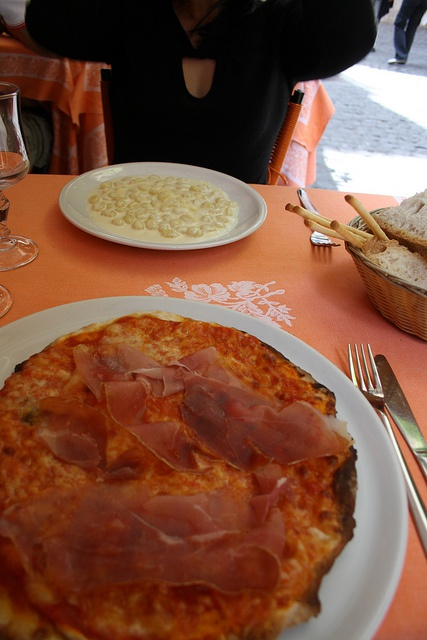Describe the objects in this image and their specific colors. I can see dining table in gray, maroon, brown, and darkgray tones, pizza in gray, maroon, and brown tones, people in gray, black, and maroon tones, fork in gray, ivory, darkgray, and maroon tones, and knife in gray, maroon, and darkgray tones in this image. 